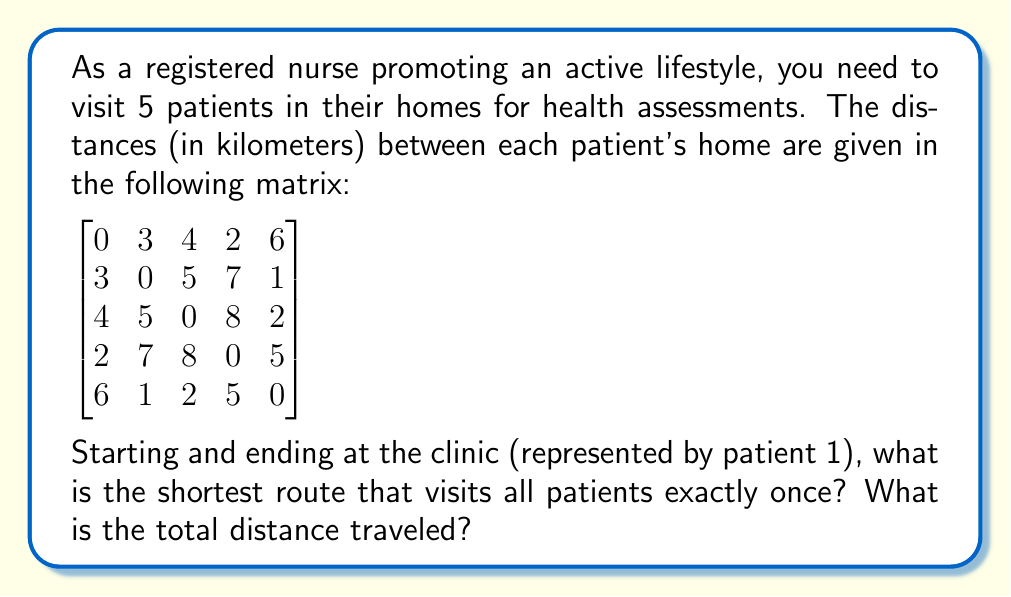Could you help me with this problem? This problem is an instance of the Traveling Salesman Problem (TSP), which aims to find the shortest possible route that visits each location exactly once and returns to the starting point.

To solve this problem, we can use the following steps:

1) List all possible routes: There are $(5-1)! = 24$ possible routes, as we start and end at the clinic (patient 1).

2) Calculate the total distance for each route:
   For example, the route 1-2-3-4-5-1 would have a distance of:
   $3 + 5 + 8 + 5 + 6 = 27$ km

3) Compare all routes to find the shortest one.

After calculating all routes, we find that the shortest route is:

1 (clinic) → 4 → 5 → 3 → 2 → 1 (clinic)

Let's calculate the total distance:
- From 1 to 4: 2 km
- From 4 to 5: 5 km
- From 5 to 3: 2 km
- From 3 to 2: 5 km
- From 2 back to 1 (clinic): 3 km

Total distance: $2 + 5 + 2 + 5 + 3 = 17$ km

This route minimizes the total distance traveled while visiting all patients once and returning to the clinic.
Answer: The shortest route is 1 → 4 → 5 → 3 → 2 → 1, with a total distance of 17 km. 